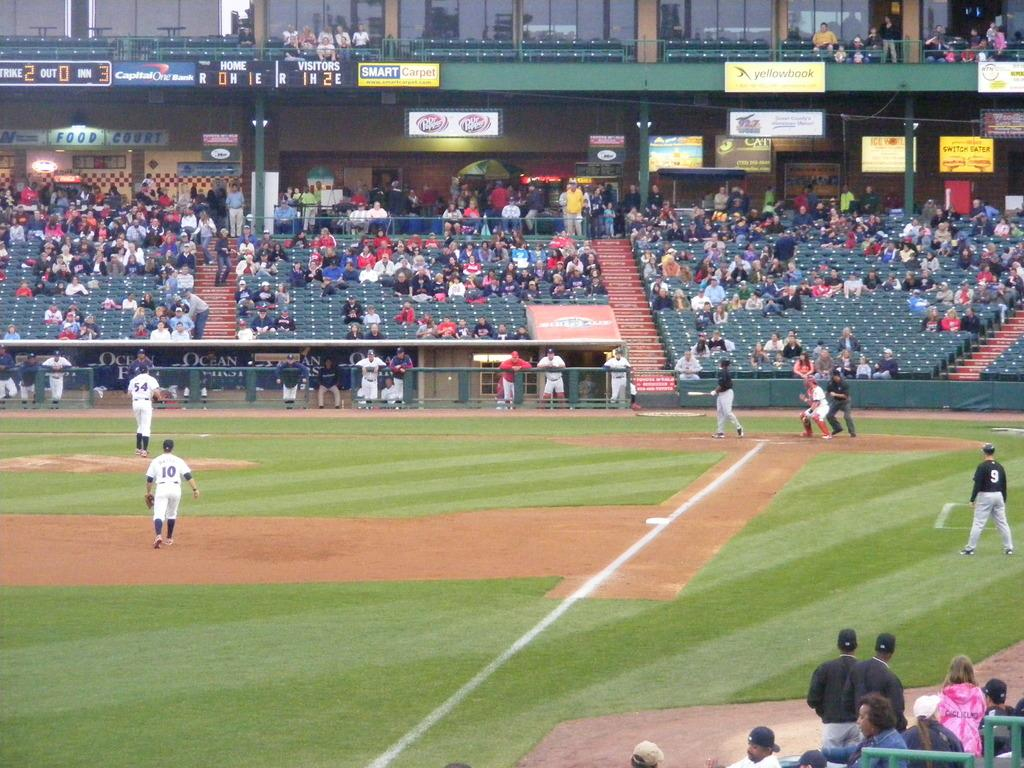What type of surface is visible in the image? There is a ground in the image. What are the people in the image doing? The players are playing a baseball game. Who is watching the baseball game? There are spectators in the image. What positions are the spectators in? The spectators are sitting and standing. What type of reward is being given to the group of people at the cemetery in the image? There is no group of people at a cemetery in the image; it features a baseball game with players and spectators. 